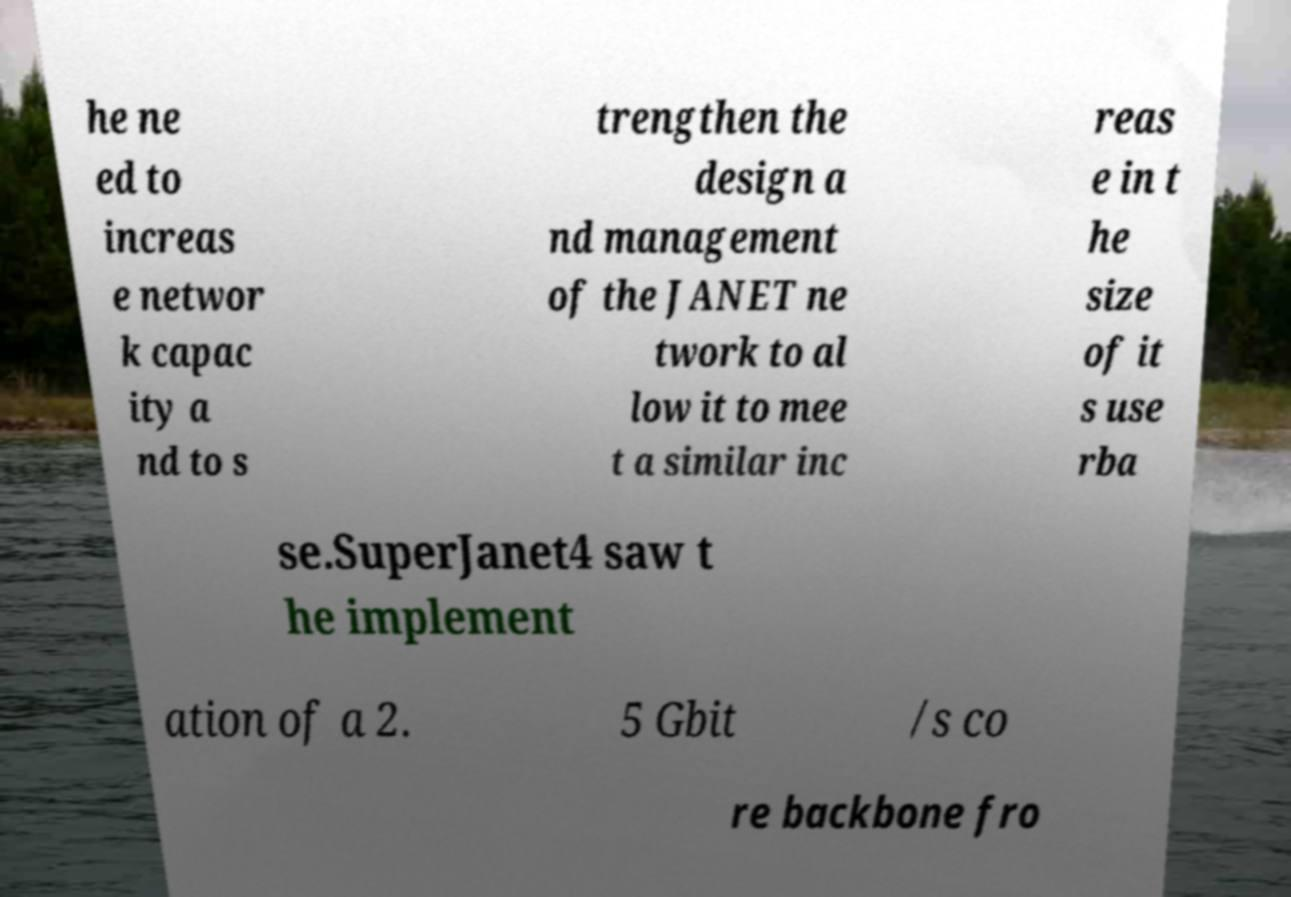Can you accurately transcribe the text from the provided image for me? he ne ed to increas e networ k capac ity a nd to s trengthen the design a nd management of the JANET ne twork to al low it to mee t a similar inc reas e in t he size of it s use rba se.SuperJanet4 saw t he implement ation of a 2. 5 Gbit /s co re backbone fro 